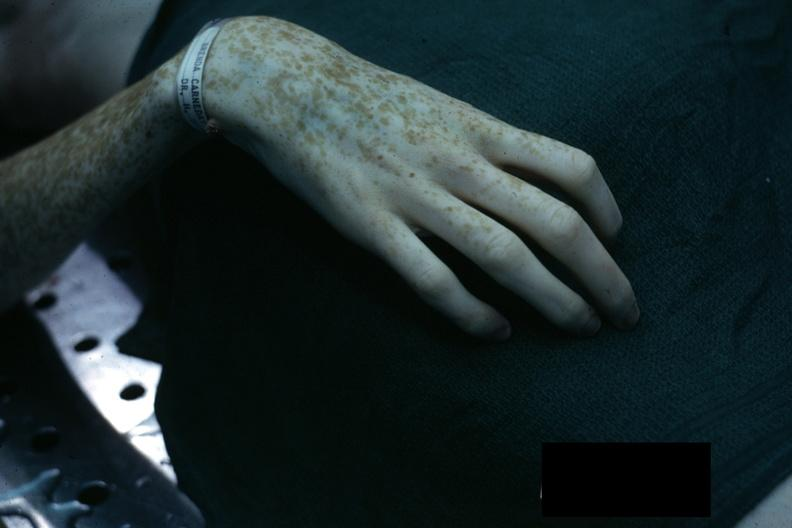s hemorrhage associated with placental abruption present?
Answer the question using a single word or phrase. No 